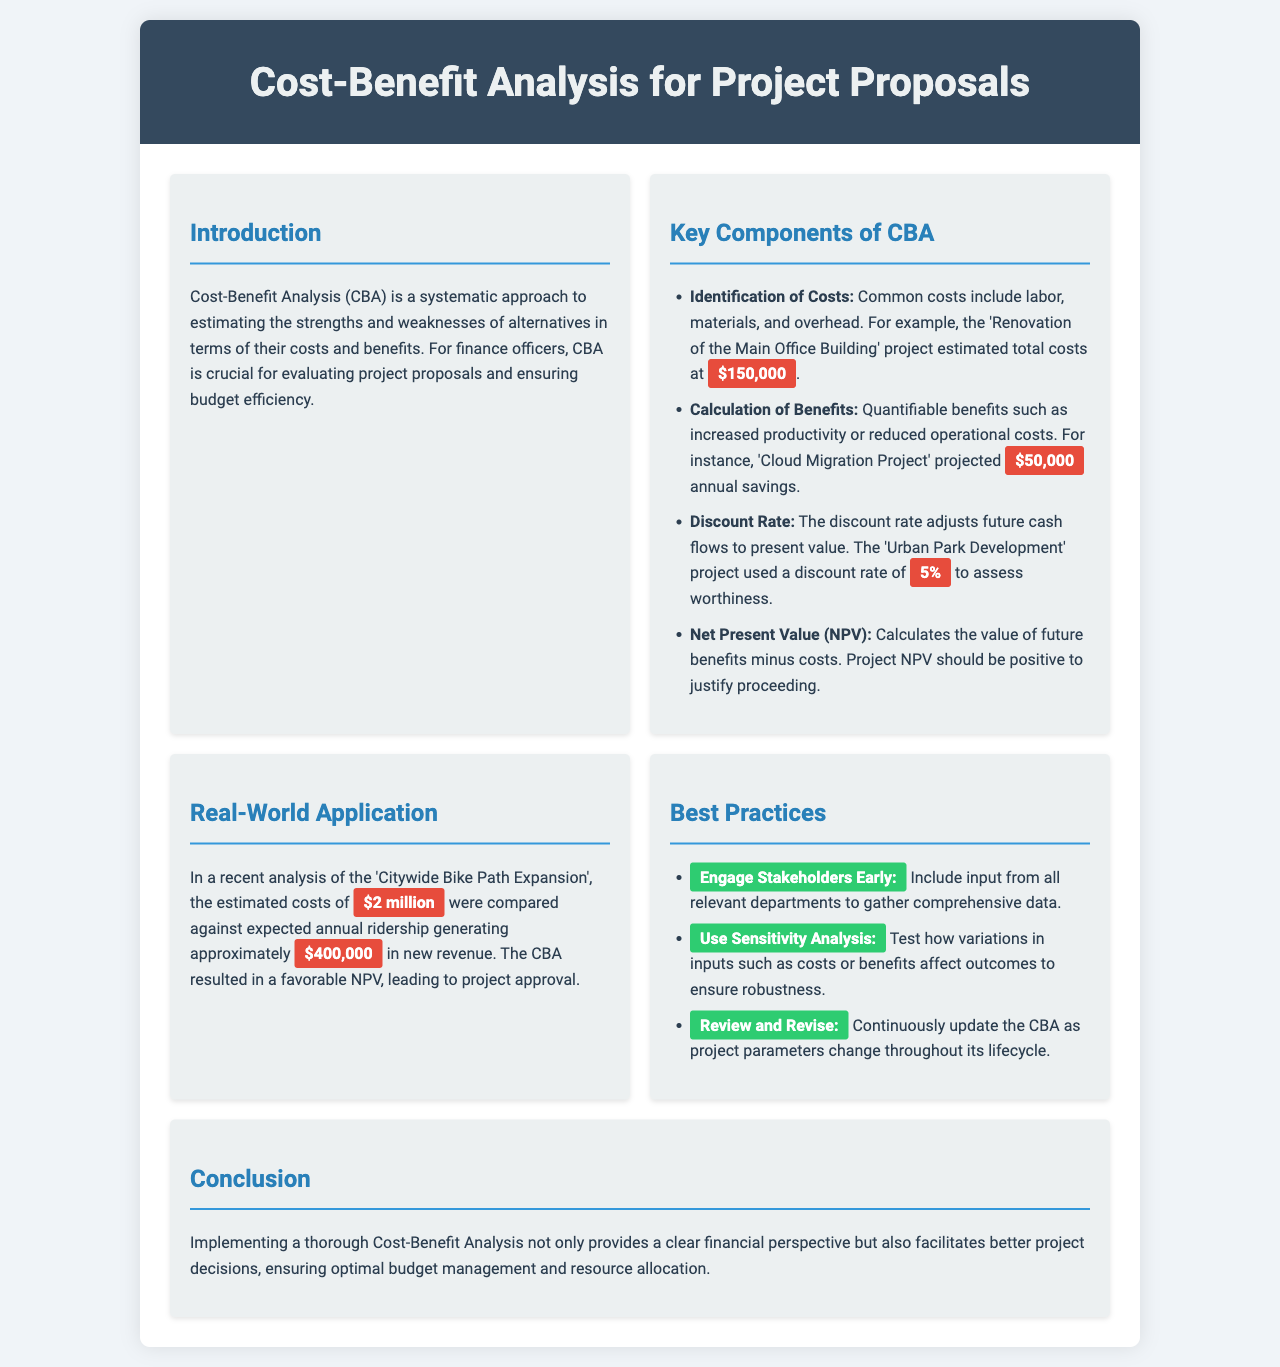What is the estimated total cost for the renovation project? The document states that the estimated total cost for the 'Renovation of the Main Office Building' project is $150,000.
Answer: $150,000 What is the annual savings projected for the Cloud Migration Project? The Cloud Migration Project projected annual savings of $50,000.
Answer: $50,000 What discount rate was used for the Urban Park Development project? The Urban Park Development project used a discount rate of 5%.
Answer: 5% What was the estimated cost for the Citywide Bike Path Expansion? It is mentioned that the estimated costs for the Citywide Bike Path Expansion were $2 million.
Answer: $2 million What is the main purpose of conducting a Cost-Benefit Analysis? The brochure states that CBA is crucial for evaluating project proposals and ensuring budget efficiency.
Answer: Evaluating project proposals What does NPV stand for? NPV refers to Net Present Value, which calculates the value of future benefits minus costs.
Answer: Net Present Value Which best practice suggests including input from other departments? The best practice that suggests including input from other departments is "Engage Stakeholders Early."
Answer: Engage Stakeholders Early What should be tested in sensitivity analysis? Sensitivity analysis should test how variations in inputs such as costs or benefits affect outcomes.
Answer: Variations in inputs What does the conclusion emphasize regarding CBA? The conclusion emphasizes that implementing a thorough CBA provides a clear financial perspective and facilitates better project decisions.
Answer: Clear financial perspective 